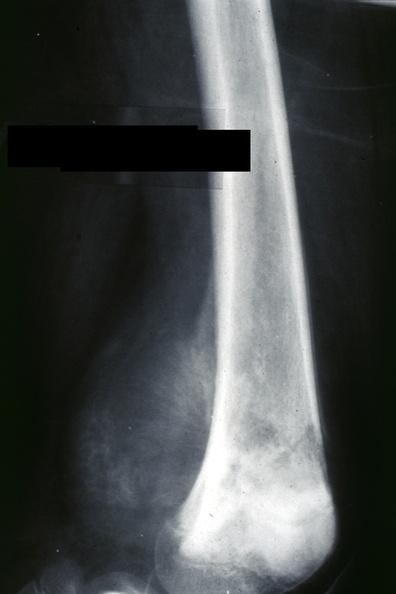what is present?
Answer the question using a single word or phrase. Joints 